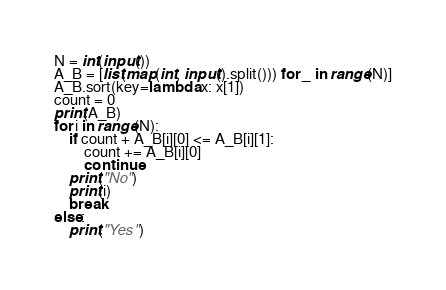<code> <loc_0><loc_0><loc_500><loc_500><_Python_>N = int(input())
A_B = [list(map(int, input().split())) for _ in range(N)]
A_B.sort(key=lambda x: x[1])
count = 0
print(A_B)
for i in range(N):
    if count + A_B[i][0] <= A_B[i][1]:
        count += A_B[i][0]
        continue
    print("No")
    print(i)
    break
else:
    print("Yes")</code> 